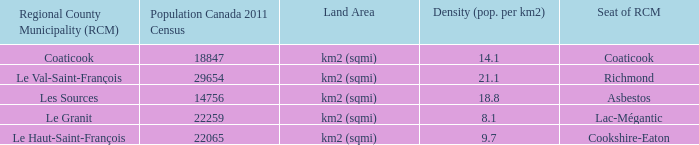What is the land area of the RCM having a density of 21.1? Km2 (sqmi). 